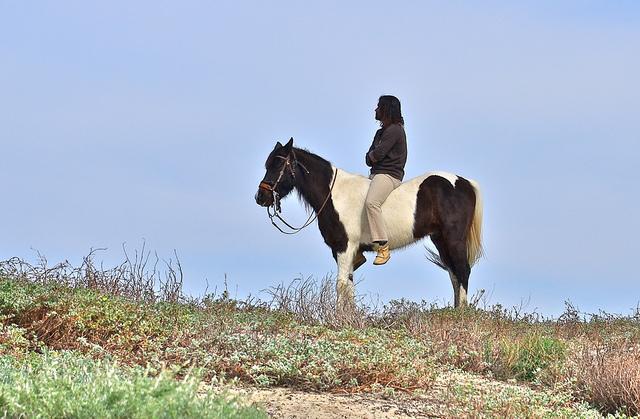How many animals are in the picture?
Give a very brief answer. 1. How many levels on this bus are red?
Give a very brief answer. 0. 